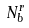Convert formula to latex. <formula><loc_0><loc_0><loc_500><loc_500>N _ { b } ^ { r }</formula> 